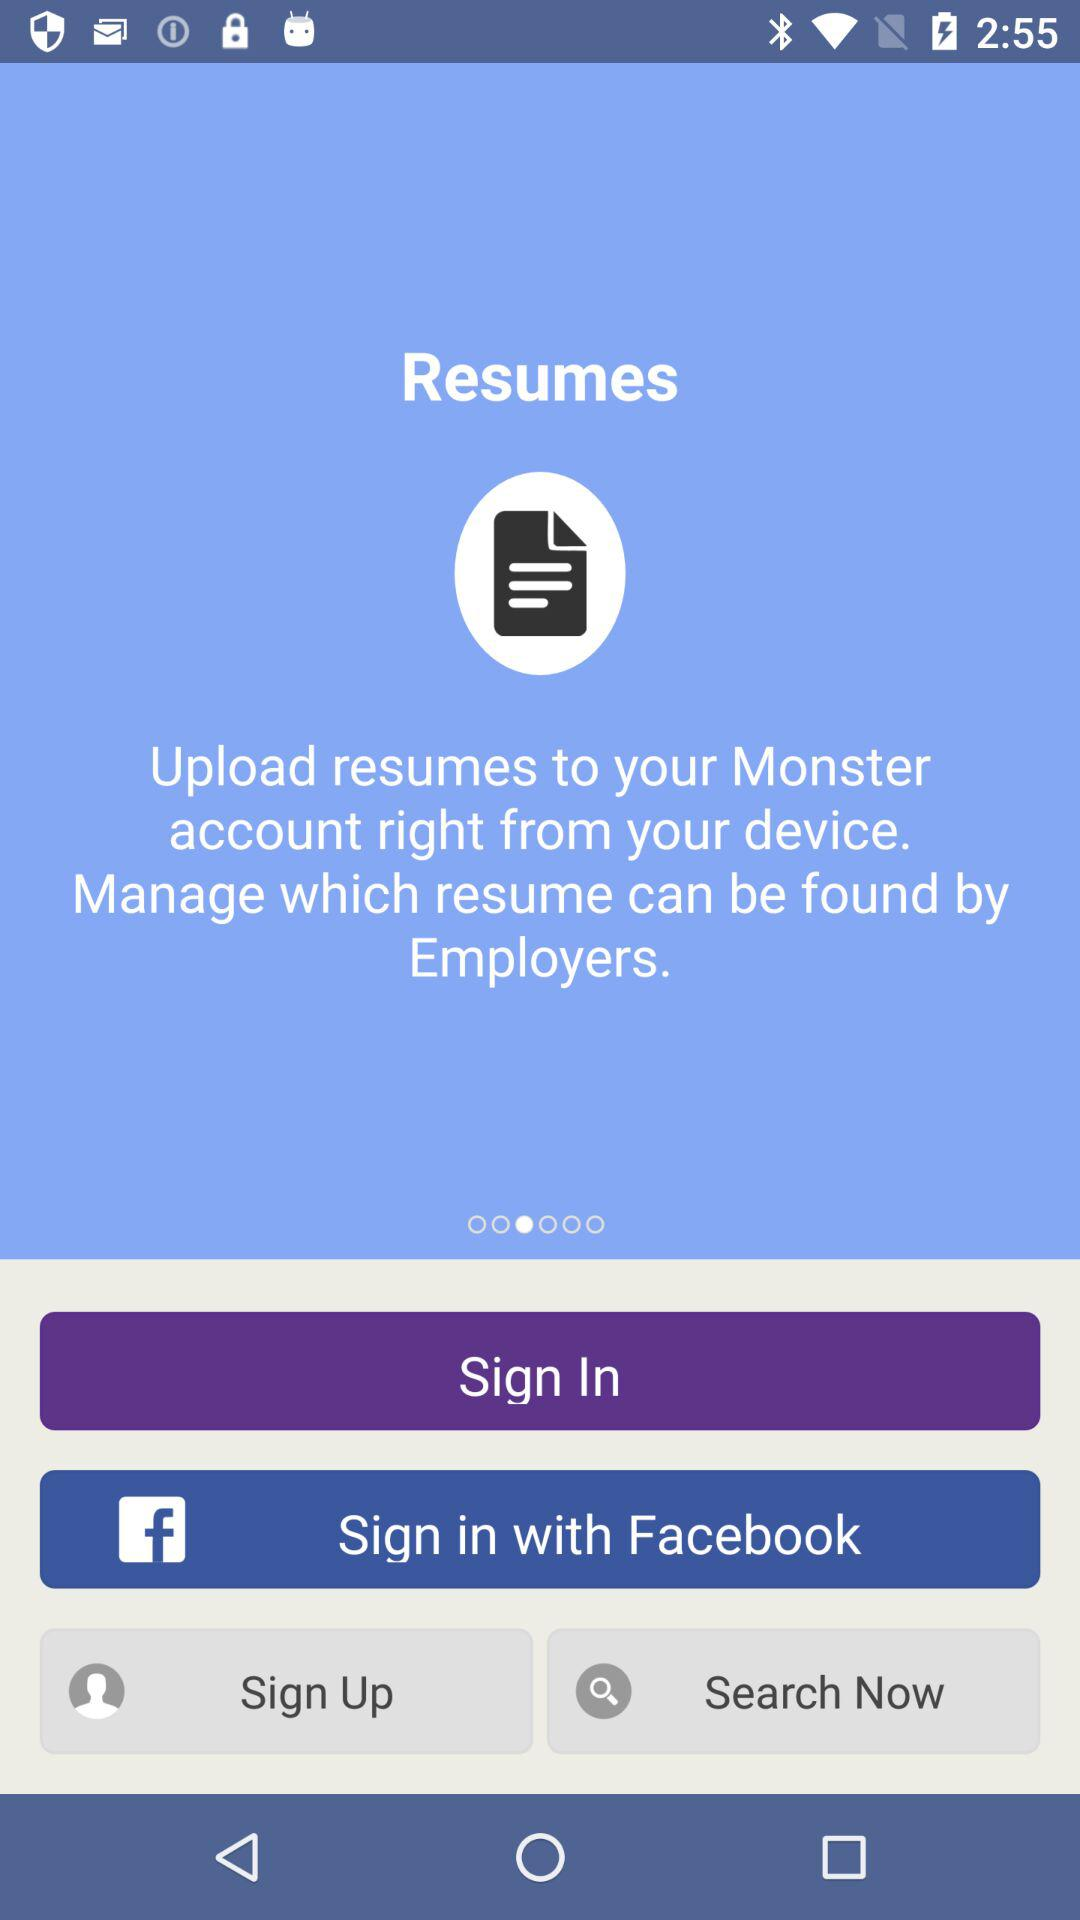How can we sign in? You can sign in with "Facebook". 